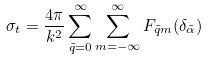<formula> <loc_0><loc_0><loc_500><loc_500>\sigma _ { t } = \frac { 4 \pi } { k ^ { 2 } } \sum _ { \tilde { q } = 0 } ^ { \infty } \sum _ { m = - \infty } ^ { \infty } F _ { \tilde { q } m } ( \delta _ { \tilde { \alpha } } )</formula> 